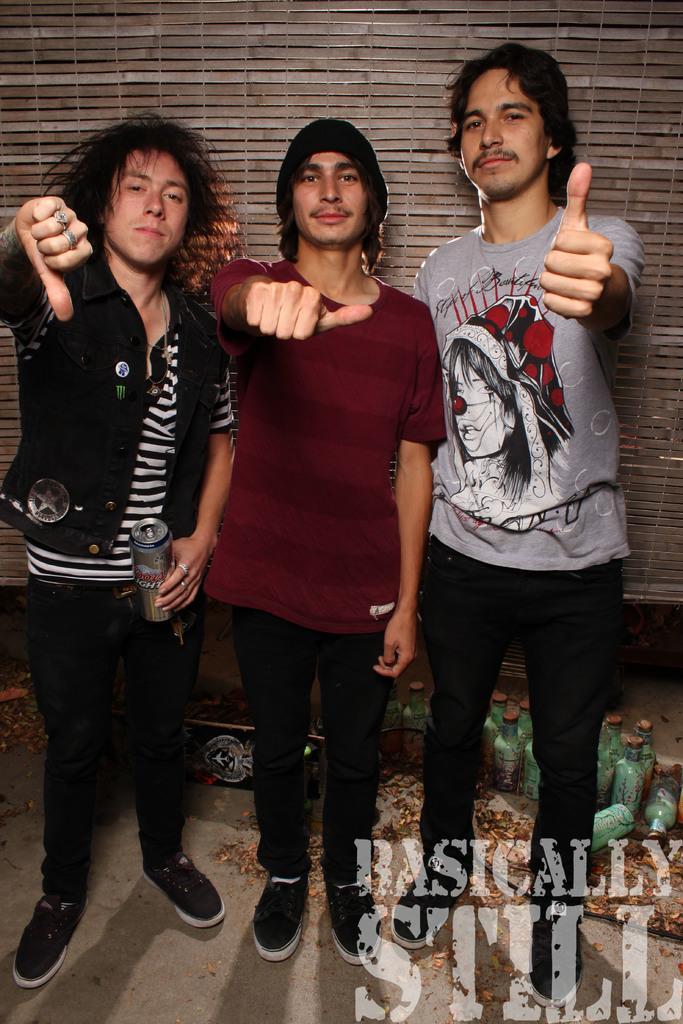Could you give a brief overview of what you see in this image? In the center of the image we can see three persons are standing. On the left side of the image a man is standing and holding a bottle in her hand. In the background of the image we can see a wall. At the bottom of the image we can see some objects and bottles are there. At the bottom right corner some text is there. At the bottom of the image floor is present. 